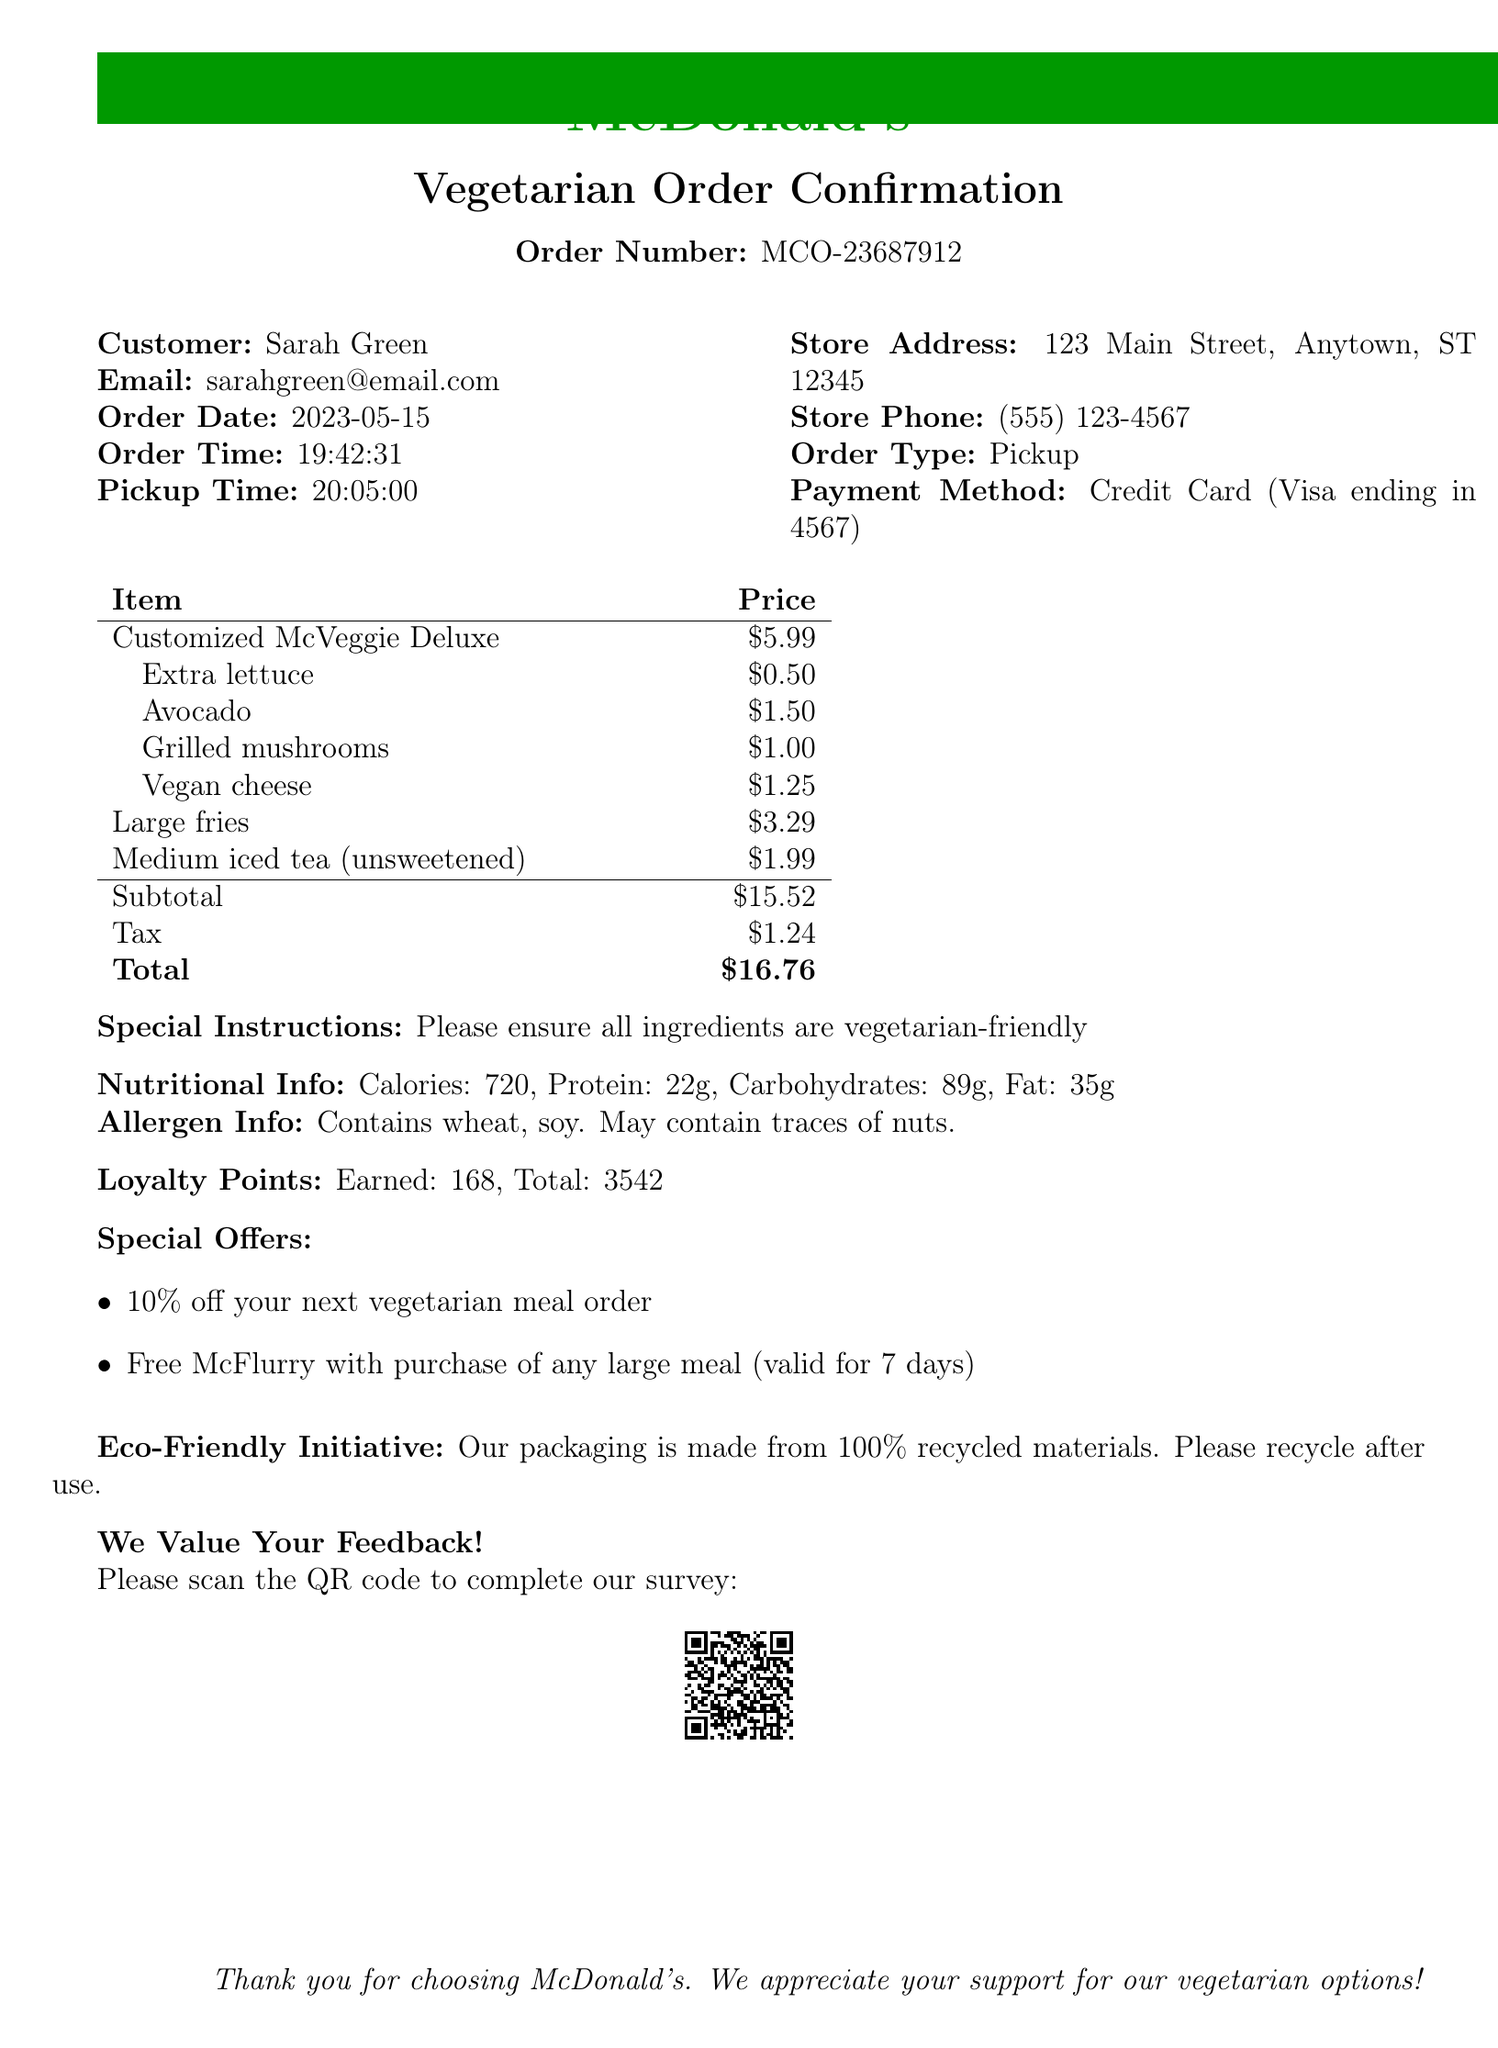What is the order number? The order number is specified clearly in the document as the unique identifier for this transaction.
Answer: MCO-23687912 What is the customer's email? The email provided in the document is the contact information for communication regarding the order.
Answer: sarahgreen@email.com What toppings did Sarah customize on her burger? The document lists all the additional toppings that were requested for the customized veggie burger.
Answer: Extra lettuce, Avocado, Grilled mushrooms, Vegan cheese What is the total amount of the order? The total amount is calculated after including the subtotal and tax, and it is clearly stated in the document.
Answer: $16.76 How many loyalty points did Sarah earn from this order? The loyalty points earned are documented along with the total points accumulated from all orders.
Answer: 168 What is the pickup time for the order? The scheduled pickup time is noted in the order details, which specifies when the customer can collect their food.
Answer: 20:05:00 What special offer does Sarah have for her next vegetarian meal? The document includes a specific offer related to future orders that is available to the customer.
Answer: 10% off your next vegetarian meal order What allergen information is provided? The document mentions specific allergens related to the food items that are part of the order, which the customer needs to be aware of.
Answer: Contains wheat, soy; May contain traces of nuts What is the eco-friendly initiative mentioned? The document includes details about the restaurant's commitment to sustainability, outlined in a specific section.
Answer: Our packaging is made from 100% recycled materials. Please recycle after use 